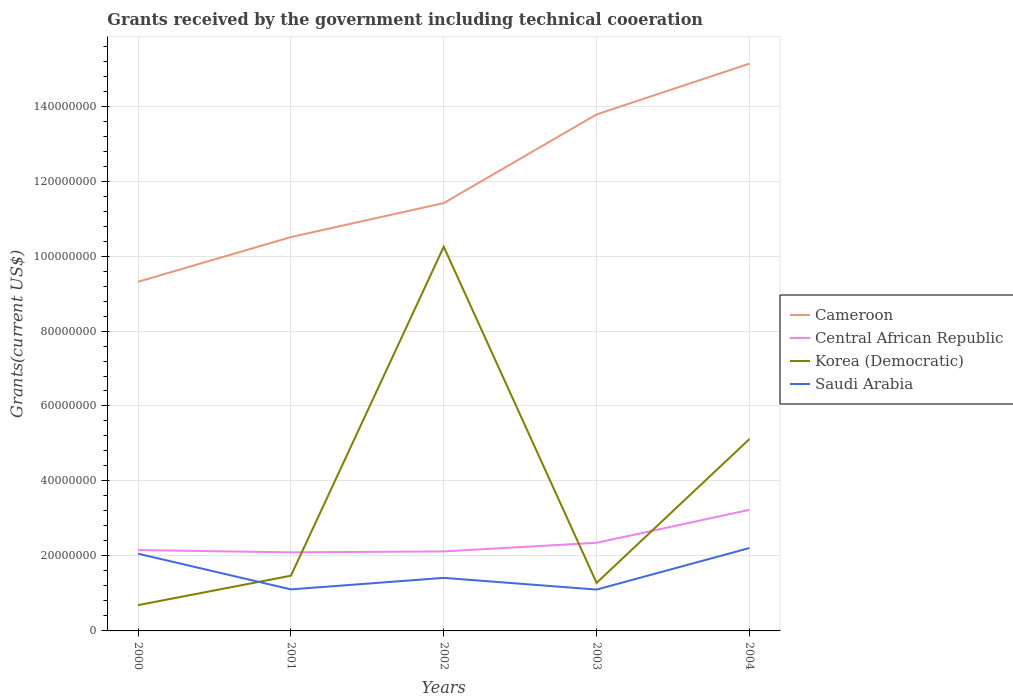How many different coloured lines are there?
Provide a succinct answer. 4. Does the line corresponding to Central African Republic intersect with the line corresponding to Saudi Arabia?
Offer a very short reply. No. Across all years, what is the maximum total grants received by the government in Cameroon?
Your answer should be compact. 9.31e+07. What is the total total grants received by the government in Korea (Democratic) in the graph?
Provide a succinct answer. -3.84e+07. What is the difference between the highest and the second highest total grants received by the government in Saudi Arabia?
Your response must be concise. 1.11e+07. How many years are there in the graph?
Your response must be concise. 5. Does the graph contain grids?
Ensure brevity in your answer.  Yes. Where does the legend appear in the graph?
Your answer should be very brief. Center right. How are the legend labels stacked?
Ensure brevity in your answer.  Vertical. What is the title of the graph?
Offer a terse response. Grants received by the government including technical cooeration. Does "World" appear as one of the legend labels in the graph?
Ensure brevity in your answer.  No. What is the label or title of the X-axis?
Keep it short and to the point. Years. What is the label or title of the Y-axis?
Your answer should be compact. Grants(current US$). What is the Grants(current US$) of Cameroon in 2000?
Your answer should be very brief. 9.31e+07. What is the Grants(current US$) in Central African Republic in 2000?
Offer a very short reply. 2.16e+07. What is the Grants(current US$) in Korea (Democratic) in 2000?
Your answer should be compact. 6.88e+06. What is the Grants(current US$) of Saudi Arabia in 2000?
Make the answer very short. 2.06e+07. What is the Grants(current US$) in Cameroon in 2001?
Keep it short and to the point. 1.05e+08. What is the Grants(current US$) of Central African Republic in 2001?
Make the answer very short. 2.10e+07. What is the Grants(current US$) in Korea (Democratic) in 2001?
Give a very brief answer. 1.47e+07. What is the Grants(current US$) of Saudi Arabia in 2001?
Give a very brief answer. 1.11e+07. What is the Grants(current US$) in Cameroon in 2002?
Keep it short and to the point. 1.14e+08. What is the Grants(current US$) in Central African Republic in 2002?
Offer a terse response. 2.12e+07. What is the Grants(current US$) of Korea (Democratic) in 2002?
Ensure brevity in your answer.  1.02e+08. What is the Grants(current US$) of Saudi Arabia in 2002?
Your answer should be very brief. 1.42e+07. What is the Grants(current US$) of Cameroon in 2003?
Provide a short and direct response. 1.38e+08. What is the Grants(current US$) of Central African Republic in 2003?
Offer a very short reply. 2.35e+07. What is the Grants(current US$) of Korea (Democratic) in 2003?
Give a very brief answer. 1.28e+07. What is the Grants(current US$) in Saudi Arabia in 2003?
Your answer should be very brief. 1.10e+07. What is the Grants(current US$) of Cameroon in 2004?
Your response must be concise. 1.51e+08. What is the Grants(current US$) of Central African Republic in 2004?
Provide a short and direct response. 3.23e+07. What is the Grants(current US$) of Korea (Democratic) in 2004?
Your answer should be compact. 5.12e+07. What is the Grants(current US$) of Saudi Arabia in 2004?
Provide a succinct answer. 2.21e+07. Across all years, what is the maximum Grants(current US$) of Cameroon?
Your answer should be very brief. 1.51e+08. Across all years, what is the maximum Grants(current US$) of Central African Republic?
Make the answer very short. 3.23e+07. Across all years, what is the maximum Grants(current US$) of Korea (Democratic)?
Provide a short and direct response. 1.02e+08. Across all years, what is the maximum Grants(current US$) of Saudi Arabia?
Your response must be concise. 2.21e+07. Across all years, what is the minimum Grants(current US$) in Cameroon?
Provide a short and direct response. 9.31e+07. Across all years, what is the minimum Grants(current US$) in Central African Republic?
Make the answer very short. 2.10e+07. Across all years, what is the minimum Grants(current US$) in Korea (Democratic)?
Your answer should be compact. 6.88e+06. Across all years, what is the minimum Grants(current US$) in Saudi Arabia?
Make the answer very short. 1.10e+07. What is the total Grants(current US$) in Cameroon in the graph?
Your answer should be compact. 6.01e+08. What is the total Grants(current US$) in Central African Republic in the graph?
Keep it short and to the point. 1.20e+08. What is the total Grants(current US$) in Korea (Democratic) in the graph?
Offer a terse response. 1.88e+08. What is the total Grants(current US$) in Saudi Arabia in the graph?
Keep it short and to the point. 7.90e+07. What is the difference between the Grants(current US$) of Cameroon in 2000 and that in 2001?
Give a very brief answer. -1.19e+07. What is the difference between the Grants(current US$) of Central African Republic in 2000 and that in 2001?
Offer a terse response. 6.10e+05. What is the difference between the Grants(current US$) of Korea (Democratic) in 2000 and that in 2001?
Offer a terse response. -7.85e+06. What is the difference between the Grants(current US$) of Saudi Arabia in 2000 and that in 2001?
Ensure brevity in your answer.  9.52e+06. What is the difference between the Grants(current US$) of Cameroon in 2000 and that in 2002?
Give a very brief answer. -2.10e+07. What is the difference between the Grants(current US$) in Korea (Democratic) in 2000 and that in 2002?
Your response must be concise. -9.56e+07. What is the difference between the Grants(current US$) of Saudi Arabia in 2000 and that in 2002?
Offer a terse response. 6.45e+06. What is the difference between the Grants(current US$) in Cameroon in 2000 and that in 2003?
Provide a short and direct response. -4.46e+07. What is the difference between the Grants(current US$) in Central African Republic in 2000 and that in 2003?
Ensure brevity in your answer.  -1.94e+06. What is the difference between the Grants(current US$) in Korea (Democratic) in 2000 and that in 2003?
Offer a terse response. -5.94e+06. What is the difference between the Grants(current US$) in Saudi Arabia in 2000 and that in 2003?
Offer a very short reply. 9.57e+06. What is the difference between the Grants(current US$) of Cameroon in 2000 and that in 2004?
Give a very brief answer. -5.82e+07. What is the difference between the Grants(current US$) of Central African Republic in 2000 and that in 2004?
Offer a terse response. -1.07e+07. What is the difference between the Grants(current US$) of Korea (Democratic) in 2000 and that in 2004?
Make the answer very short. -4.43e+07. What is the difference between the Grants(current US$) in Saudi Arabia in 2000 and that in 2004?
Offer a very short reply. -1.51e+06. What is the difference between the Grants(current US$) in Cameroon in 2001 and that in 2002?
Offer a very short reply. -9.07e+06. What is the difference between the Grants(current US$) of Korea (Democratic) in 2001 and that in 2002?
Give a very brief answer. -8.77e+07. What is the difference between the Grants(current US$) of Saudi Arabia in 2001 and that in 2002?
Make the answer very short. -3.07e+06. What is the difference between the Grants(current US$) in Cameroon in 2001 and that in 2003?
Keep it short and to the point. -3.27e+07. What is the difference between the Grants(current US$) in Central African Republic in 2001 and that in 2003?
Provide a succinct answer. -2.55e+06. What is the difference between the Grants(current US$) of Korea (Democratic) in 2001 and that in 2003?
Your response must be concise. 1.91e+06. What is the difference between the Grants(current US$) in Cameroon in 2001 and that in 2004?
Your answer should be very brief. -4.63e+07. What is the difference between the Grants(current US$) of Central African Republic in 2001 and that in 2004?
Your answer should be very brief. -1.13e+07. What is the difference between the Grants(current US$) in Korea (Democratic) in 2001 and that in 2004?
Give a very brief answer. -3.64e+07. What is the difference between the Grants(current US$) of Saudi Arabia in 2001 and that in 2004?
Your answer should be compact. -1.10e+07. What is the difference between the Grants(current US$) in Cameroon in 2002 and that in 2003?
Give a very brief answer. -2.36e+07. What is the difference between the Grants(current US$) of Central African Republic in 2002 and that in 2003?
Your answer should be very brief. -2.30e+06. What is the difference between the Grants(current US$) in Korea (Democratic) in 2002 and that in 2003?
Offer a terse response. 8.96e+07. What is the difference between the Grants(current US$) in Saudi Arabia in 2002 and that in 2003?
Offer a terse response. 3.12e+06. What is the difference between the Grants(current US$) in Cameroon in 2002 and that in 2004?
Offer a very short reply. -3.72e+07. What is the difference between the Grants(current US$) in Central African Republic in 2002 and that in 2004?
Your answer should be very brief. -1.11e+07. What is the difference between the Grants(current US$) of Korea (Democratic) in 2002 and that in 2004?
Your response must be concise. 5.13e+07. What is the difference between the Grants(current US$) of Saudi Arabia in 2002 and that in 2004?
Offer a very short reply. -7.96e+06. What is the difference between the Grants(current US$) in Cameroon in 2003 and that in 2004?
Keep it short and to the point. -1.35e+07. What is the difference between the Grants(current US$) in Central African Republic in 2003 and that in 2004?
Your answer should be compact. -8.79e+06. What is the difference between the Grants(current US$) of Korea (Democratic) in 2003 and that in 2004?
Offer a very short reply. -3.84e+07. What is the difference between the Grants(current US$) in Saudi Arabia in 2003 and that in 2004?
Provide a short and direct response. -1.11e+07. What is the difference between the Grants(current US$) in Cameroon in 2000 and the Grants(current US$) in Central African Republic in 2001?
Ensure brevity in your answer.  7.22e+07. What is the difference between the Grants(current US$) of Cameroon in 2000 and the Grants(current US$) of Korea (Democratic) in 2001?
Offer a very short reply. 7.84e+07. What is the difference between the Grants(current US$) in Cameroon in 2000 and the Grants(current US$) in Saudi Arabia in 2001?
Keep it short and to the point. 8.20e+07. What is the difference between the Grants(current US$) in Central African Republic in 2000 and the Grants(current US$) in Korea (Democratic) in 2001?
Provide a short and direct response. 6.84e+06. What is the difference between the Grants(current US$) of Central African Republic in 2000 and the Grants(current US$) of Saudi Arabia in 2001?
Offer a terse response. 1.05e+07. What is the difference between the Grants(current US$) in Korea (Democratic) in 2000 and the Grants(current US$) in Saudi Arabia in 2001?
Your response must be concise. -4.20e+06. What is the difference between the Grants(current US$) of Cameroon in 2000 and the Grants(current US$) of Central African Republic in 2002?
Keep it short and to the point. 7.19e+07. What is the difference between the Grants(current US$) in Cameroon in 2000 and the Grants(current US$) in Korea (Democratic) in 2002?
Offer a terse response. -9.34e+06. What is the difference between the Grants(current US$) in Cameroon in 2000 and the Grants(current US$) in Saudi Arabia in 2002?
Your answer should be very brief. 7.90e+07. What is the difference between the Grants(current US$) of Central African Republic in 2000 and the Grants(current US$) of Korea (Democratic) in 2002?
Offer a very short reply. -8.09e+07. What is the difference between the Grants(current US$) in Central African Republic in 2000 and the Grants(current US$) in Saudi Arabia in 2002?
Your answer should be very brief. 7.42e+06. What is the difference between the Grants(current US$) in Korea (Democratic) in 2000 and the Grants(current US$) in Saudi Arabia in 2002?
Keep it short and to the point. -7.27e+06. What is the difference between the Grants(current US$) of Cameroon in 2000 and the Grants(current US$) of Central African Republic in 2003?
Ensure brevity in your answer.  6.96e+07. What is the difference between the Grants(current US$) in Cameroon in 2000 and the Grants(current US$) in Korea (Democratic) in 2003?
Your response must be concise. 8.03e+07. What is the difference between the Grants(current US$) of Cameroon in 2000 and the Grants(current US$) of Saudi Arabia in 2003?
Offer a very short reply. 8.21e+07. What is the difference between the Grants(current US$) in Central African Republic in 2000 and the Grants(current US$) in Korea (Democratic) in 2003?
Provide a short and direct response. 8.75e+06. What is the difference between the Grants(current US$) of Central African Republic in 2000 and the Grants(current US$) of Saudi Arabia in 2003?
Give a very brief answer. 1.05e+07. What is the difference between the Grants(current US$) of Korea (Democratic) in 2000 and the Grants(current US$) of Saudi Arabia in 2003?
Make the answer very short. -4.15e+06. What is the difference between the Grants(current US$) of Cameroon in 2000 and the Grants(current US$) of Central African Republic in 2004?
Your answer should be very brief. 6.08e+07. What is the difference between the Grants(current US$) of Cameroon in 2000 and the Grants(current US$) of Korea (Democratic) in 2004?
Ensure brevity in your answer.  4.20e+07. What is the difference between the Grants(current US$) in Cameroon in 2000 and the Grants(current US$) in Saudi Arabia in 2004?
Offer a terse response. 7.10e+07. What is the difference between the Grants(current US$) in Central African Republic in 2000 and the Grants(current US$) in Korea (Democratic) in 2004?
Your response must be concise. -2.96e+07. What is the difference between the Grants(current US$) in Central African Republic in 2000 and the Grants(current US$) in Saudi Arabia in 2004?
Offer a terse response. -5.40e+05. What is the difference between the Grants(current US$) in Korea (Democratic) in 2000 and the Grants(current US$) in Saudi Arabia in 2004?
Offer a terse response. -1.52e+07. What is the difference between the Grants(current US$) of Cameroon in 2001 and the Grants(current US$) of Central African Republic in 2002?
Ensure brevity in your answer.  8.38e+07. What is the difference between the Grants(current US$) of Cameroon in 2001 and the Grants(current US$) of Korea (Democratic) in 2002?
Provide a succinct answer. 2.59e+06. What is the difference between the Grants(current US$) in Cameroon in 2001 and the Grants(current US$) in Saudi Arabia in 2002?
Your response must be concise. 9.09e+07. What is the difference between the Grants(current US$) of Central African Republic in 2001 and the Grants(current US$) of Korea (Democratic) in 2002?
Give a very brief answer. -8.15e+07. What is the difference between the Grants(current US$) in Central African Republic in 2001 and the Grants(current US$) in Saudi Arabia in 2002?
Provide a short and direct response. 6.81e+06. What is the difference between the Grants(current US$) of Korea (Democratic) in 2001 and the Grants(current US$) of Saudi Arabia in 2002?
Your response must be concise. 5.80e+05. What is the difference between the Grants(current US$) in Cameroon in 2001 and the Grants(current US$) in Central African Republic in 2003?
Make the answer very short. 8.16e+07. What is the difference between the Grants(current US$) in Cameroon in 2001 and the Grants(current US$) in Korea (Democratic) in 2003?
Keep it short and to the point. 9.22e+07. What is the difference between the Grants(current US$) of Cameroon in 2001 and the Grants(current US$) of Saudi Arabia in 2003?
Your answer should be very brief. 9.40e+07. What is the difference between the Grants(current US$) in Central African Republic in 2001 and the Grants(current US$) in Korea (Democratic) in 2003?
Provide a succinct answer. 8.14e+06. What is the difference between the Grants(current US$) in Central African Republic in 2001 and the Grants(current US$) in Saudi Arabia in 2003?
Provide a short and direct response. 9.93e+06. What is the difference between the Grants(current US$) of Korea (Democratic) in 2001 and the Grants(current US$) of Saudi Arabia in 2003?
Provide a short and direct response. 3.70e+06. What is the difference between the Grants(current US$) of Cameroon in 2001 and the Grants(current US$) of Central African Republic in 2004?
Offer a very short reply. 7.28e+07. What is the difference between the Grants(current US$) in Cameroon in 2001 and the Grants(current US$) in Korea (Democratic) in 2004?
Ensure brevity in your answer.  5.39e+07. What is the difference between the Grants(current US$) of Cameroon in 2001 and the Grants(current US$) of Saudi Arabia in 2004?
Ensure brevity in your answer.  8.30e+07. What is the difference between the Grants(current US$) in Central African Republic in 2001 and the Grants(current US$) in Korea (Democratic) in 2004?
Give a very brief answer. -3.02e+07. What is the difference between the Grants(current US$) of Central African Republic in 2001 and the Grants(current US$) of Saudi Arabia in 2004?
Offer a terse response. -1.15e+06. What is the difference between the Grants(current US$) of Korea (Democratic) in 2001 and the Grants(current US$) of Saudi Arabia in 2004?
Ensure brevity in your answer.  -7.38e+06. What is the difference between the Grants(current US$) in Cameroon in 2002 and the Grants(current US$) in Central African Republic in 2003?
Offer a terse response. 9.06e+07. What is the difference between the Grants(current US$) of Cameroon in 2002 and the Grants(current US$) of Korea (Democratic) in 2003?
Offer a terse response. 1.01e+08. What is the difference between the Grants(current US$) in Cameroon in 2002 and the Grants(current US$) in Saudi Arabia in 2003?
Provide a short and direct response. 1.03e+08. What is the difference between the Grants(current US$) of Central African Republic in 2002 and the Grants(current US$) of Korea (Democratic) in 2003?
Your response must be concise. 8.39e+06. What is the difference between the Grants(current US$) in Central African Republic in 2002 and the Grants(current US$) in Saudi Arabia in 2003?
Provide a succinct answer. 1.02e+07. What is the difference between the Grants(current US$) of Korea (Democratic) in 2002 and the Grants(current US$) of Saudi Arabia in 2003?
Your answer should be compact. 9.14e+07. What is the difference between the Grants(current US$) of Cameroon in 2002 and the Grants(current US$) of Central African Republic in 2004?
Provide a short and direct response. 8.18e+07. What is the difference between the Grants(current US$) in Cameroon in 2002 and the Grants(current US$) in Korea (Democratic) in 2004?
Offer a very short reply. 6.30e+07. What is the difference between the Grants(current US$) in Cameroon in 2002 and the Grants(current US$) in Saudi Arabia in 2004?
Your response must be concise. 9.20e+07. What is the difference between the Grants(current US$) of Central African Republic in 2002 and the Grants(current US$) of Korea (Democratic) in 2004?
Your answer should be very brief. -3.00e+07. What is the difference between the Grants(current US$) of Central African Republic in 2002 and the Grants(current US$) of Saudi Arabia in 2004?
Give a very brief answer. -9.00e+05. What is the difference between the Grants(current US$) of Korea (Democratic) in 2002 and the Grants(current US$) of Saudi Arabia in 2004?
Offer a very short reply. 8.04e+07. What is the difference between the Grants(current US$) in Cameroon in 2003 and the Grants(current US$) in Central African Republic in 2004?
Provide a short and direct response. 1.05e+08. What is the difference between the Grants(current US$) of Cameroon in 2003 and the Grants(current US$) of Korea (Democratic) in 2004?
Ensure brevity in your answer.  8.66e+07. What is the difference between the Grants(current US$) of Cameroon in 2003 and the Grants(current US$) of Saudi Arabia in 2004?
Give a very brief answer. 1.16e+08. What is the difference between the Grants(current US$) of Central African Republic in 2003 and the Grants(current US$) of Korea (Democratic) in 2004?
Give a very brief answer. -2.77e+07. What is the difference between the Grants(current US$) in Central African Republic in 2003 and the Grants(current US$) in Saudi Arabia in 2004?
Make the answer very short. 1.40e+06. What is the difference between the Grants(current US$) in Korea (Democratic) in 2003 and the Grants(current US$) in Saudi Arabia in 2004?
Give a very brief answer. -9.29e+06. What is the average Grants(current US$) of Cameroon per year?
Give a very brief answer. 1.20e+08. What is the average Grants(current US$) of Central African Republic per year?
Ensure brevity in your answer.  2.39e+07. What is the average Grants(current US$) of Korea (Democratic) per year?
Offer a terse response. 3.76e+07. What is the average Grants(current US$) of Saudi Arabia per year?
Your answer should be compact. 1.58e+07. In the year 2000, what is the difference between the Grants(current US$) of Cameroon and Grants(current US$) of Central African Republic?
Keep it short and to the point. 7.16e+07. In the year 2000, what is the difference between the Grants(current US$) in Cameroon and Grants(current US$) in Korea (Democratic)?
Your answer should be compact. 8.62e+07. In the year 2000, what is the difference between the Grants(current US$) in Cameroon and Grants(current US$) in Saudi Arabia?
Make the answer very short. 7.25e+07. In the year 2000, what is the difference between the Grants(current US$) in Central African Republic and Grants(current US$) in Korea (Democratic)?
Provide a succinct answer. 1.47e+07. In the year 2000, what is the difference between the Grants(current US$) of Central African Republic and Grants(current US$) of Saudi Arabia?
Give a very brief answer. 9.70e+05. In the year 2000, what is the difference between the Grants(current US$) in Korea (Democratic) and Grants(current US$) in Saudi Arabia?
Your answer should be very brief. -1.37e+07. In the year 2001, what is the difference between the Grants(current US$) in Cameroon and Grants(current US$) in Central African Republic?
Offer a very short reply. 8.41e+07. In the year 2001, what is the difference between the Grants(current US$) in Cameroon and Grants(current US$) in Korea (Democratic)?
Provide a short and direct response. 9.03e+07. In the year 2001, what is the difference between the Grants(current US$) in Cameroon and Grants(current US$) in Saudi Arabia?
Provide a short and direct response. 9.40e+07. In the year 2001, what is the difference between the Grants(current US$) in Central African Republic and Grants(current US$) in Korea (Democratic)?
Provide a succinct answer. 6.23e+06. In the year 2001, what is the difference between the Grants(current US$) in Central African Republic and Grants(current US$) in Saudi Arabia?
Provide a short and direct response. 9.88e+06. In the year 2001, what is the difference between the Grants(current US$) of Korea (Democratic) and Grants(current US$) of Saudi Arabia?
Give a very brief answer. 3.65e+06. In the year 2002, what is the difference between the Grants(current US$) of Cameroon and Grants(current US$) of Central African Republic?
Ensure brevity in your answer.  9.29e+07. In the year 2002, what is the difference between the Grants(current US$) in Cameroon and Grants(current US$) in Korea (Democratic)?
Give a very brief answer. 1.17e+07. In the year 2002, what is the difference between the Grants(current US$) in Cameroon and Grants(current US$) in Saudi Arabia?
Offer a very short reply. 1.00e+08. In the year 2002, what is the difference between the Grants(current US$) in Central African Republic and Grants(current US$) in Korea (Democratic)?
Give a very brief answer. -8.13e+07. In the year 2002, what is the difference between the Grants(current US$) of Central African Republic and Grants(current US$) of Saudi Arabia?
Offer a terse response. 7.06e+06. In the year 2002, what is the difference between the Grants(current US$) in Korea (Democratic) and Grants(current US$) in Saudi Arabia?
Ensure brevity in your answer.  8.83e+07. In the year 2003, what is the difference between the Grants(current US$) in Cameroon and Grants(current US$) in Central African Republic?
Your answer should be very brief. 1.14e+08. In the year 2003, what is the difference between the Grants(current US$) in Cameroon and Grants(current US$) in Korea (Democratic)?
Your answer should be very brief. 1.25e+08. In the year 2003, what is the difference between the Grants(current US$) of Cameroon and Grants(current US$) of Saudi Arabia?
Your answer should be compact. 1.27e+08. In the year 2003, what is the difference between the Grants(current US$) of Central African Republic and Grants(current US$) of Korea (Democratic)?
Give a very brief answer. 1.07e+07. In the year 2003, what is the difference between the Grants(current US$) in Central African Republic and Grants(current US$) in Saudi Arabia?
Your response must be concise. 1.25e+07. In the year 2003, what is the difference between the Grants(current US$) of Korea (Democratic) and Grants(current US$) of Saudi Arabia?
Keep it short and to the point. 1.79e+06. In the year 2004, what is the difference between the Grants(current US$) in Cameroon and Grants(current US$) in Central African Republic?
Your response must be concise. 1.19e+08. In the year 2004, what is the difference between the Grants(current US$) of Cameroon and Grants(current US$) of Korea (Democratic)?
Your response must be concise. 1.00e+08. In the year 2004, what is the difference between the Grants(current US$) in Cameroon and Grants(current US$) in Saudi Arabia?
Offer a terse response. 1.29e+08. In the year 2004, what is the difference between the Grants(current US$) in Central African Republic and Grants(current US$) in Korea (Democratic)?
Keep it short and to the point. -1.89e+07. In the year 2004, what is the difference between the Grants(current US$) of Central African Republic and Grants(current US$) of Saudi Arabia?
Give a very brief answer. 1.02e+07. In the year 2004, what is the difference between the Grants(current US$) of Korea (Democratic) and Grants(current US$) of Saudi Arabia?
Offer a terse response. 2.91e+07. What is the ratio of the Grants(current US$) of Cameroon in 2000 to that in 2001?
Your answer should be very brief. 0.89. What is the ratio of the Grants(current US$) in Central African Republic in 2000 to that in 2001?
Make the answer very short. 1.03. What is the ratio of the Grants(current US$) of Korea (Democratic) in 2000 to that in 2001?
Give a very brief answer. 0.47. What is the ratio of the Grants(current US$) in Saudi Arabia in 2000 to that in 2001?
Your response must be concise. 1.86. What is the ratio of the Grants(current US$) of Cameroon in 2000 to that in 2002?
Offer a very short reply. 0.82. What is the ratio of the Grants(current US$) of Central African Republic in 2000 to that in 2002?
Offer a very short reply. 1.02. What is the ratio of the Grants(current US$) in Korea (Democratic) in 2000 to that in 2002?
Make the answer very short. 0.07. What is the ratio of the Grants(current US$) in Saudi Arabia in 2000 to that in 2002?
Your answer should be very brief. 1.46. What is the ratio of the Grants(current US$) of Cameroon in 2000 to that in 2003?
Provide a short and direct response. 0.68. What is the ratio of the Grants(current US$) in Central African Republic in 2000 to that in 2003?
Your answer should be very brief. 0.92. What is the ratio of the Grants(current US$) in Korea (Democratic) in 2000 to that in 2003?
Provide a succinct answer. 0.54. What is the ratio of the Grants(current US$) of Saudi Arabia in 2000 to that in 2003?
Your response must be concise. 1.87. What is the ratio of the Grants(current US$) of Cameroon in 2000 to that in 2004?
Offer a terse response. 0.62. What is the ratio of the Grants(current US$) in Central African Republic in 2000 to that in 2004?
Make the answer very short. 0.67. What is the ratio of the Grants(current US$) in Korea (Democratic) in 2000 to that in 2004?
Give a very brief answer. 0.13. What is the ratio of the Grants(current US$) of Saudi Arabia in 2000 to that in 2004?
Keep it short and to the point. 0.93. What is the ratio of the Grants(current US$) in Cameroon in 2001 to that in 2002?
Your answer should be very brief. 0.92. What is the ratio of the Grants(current US$) in Korea (Democratic) in 2001 to that in 2002?
Provide a short and direct response. 0.14. What is the ratio of the Grants(current US$) of Saudi Arabia in 2001 to that in 2002?
Offer a terse response. 0.78. What is the ratio of the Grants(current US$) in Cameroon in 2001 to that in 2003?
Provide a short and direct response. 0.76. What is the ratio of the Grants(current US$) of Central African Republic in 2001 to that in 2003?
Offer a terse response. 0.89. What is the ratio of the Grants(current US$) in Korea (Democratic) in 2001 to that in 2003?
Provide a short and direct response. 1.15. What is the ratio of the Grants(current US$) of Cameroon in 2001 to that in 2004?
Make the answer very short. 0.69. What is the ratio of the Grants(current US$) of Central African Republic in 2001 to that in 2004?
Keep it short and to the point. 0.65. What is the ratio of the Grants(current US$) of Korea (Democratic) in 2001 to that in 2004?
Offer a very short reply. 0.29. What is the ratio of the Grants(current US$) of Saudi Arabia in 2001 to that in 2004?
Give a very brief answer. 0.5. What is the ratio of the Grants(current US$) in Cameroon in 2002 to that in 2003?
Give a very brief answer. 0.83. What is the ratio of the Grants(current US$) of Central African Republic in 2002 to that in 2003?
Offer a terse response. 0.9. What is the ratio of the Grants(current US$) of Korea (Democratic) in 2002 to that in 2003?
Make the answer very short. 7.99. What is the ratio of the Grants(current US$) in Saudi Arabia in 2002 to that in 2003?
Your response must be concise. 1.28. What is the ratio of the Grants(current US$) of Cameroon in 2002 to that in 2004?
Provide a succinct answer. 0.75. What is the ratio of the Grants(current US$) in Central African Republic in 2002 to that in 2004?
Ensure brevity in your answer.  0.66. What is the ratio of the Grants(current US$) of Korea (Democratic) in 2002 to that in 2004?
Make the answer very short. 2. What is the ratio of the Grants(current US$) of Saudi Arabia in 2002 to that in 2004?
Your response must be concise. 0.64. What is the ratio of the Grants(current US$) in Cameroon in 2003 to that in 2004?
Ensure brevity in your answer.  0.91. What is the ratio of the Grants(current US$) in Central African Republic in 2003 to that in 2004?
Ensure brevity in your answer.  0.73. What is the ratio of the Grants(current US$) of Korea (Democratic) in 2003 to that in 2004?
Your response must be concise. 0.25. What is the ratio of the Grants(current US$) of Saudi Arabia in 2003 to that in 2004?
Provide a short and direct response. 0.5. What is the difference between the highest and the second highest Grants(current US$) in Cameroon?
Offer a terse response. 1.35e+07. What is the difference between the highest and the second highest Grants(current US$) in Central African Republic?
Keep it short and to the point. 8.79e+06. What is the difference between the highest and the second highest Grants(current US$) in Korea (Democratic)?
Your response must be concise. 5.13e+07. What is the difference between the highest and the second highest Grants(current US$) in Saudi Arabia?
Keep it short and to the point. 1.51e+06. What is the difference between the highest and the lowest Grants(current US$) in Cameroon?
Your answer should be compact. 5.82e+07. What is the difference between the highest and the lowest Grants(current US$) of Central African Republic?
Keep it short and to the point. 1.13e+07. What is the difference between the highest and the lowest Grants(current US$) of Korea (Democratic)?
Give a very brief answer. 9.56e+07. What is the difference between the highest and the lowest Grants(current US$) of Saudi Arabia?
Offer a very short reply. 1.11e+07. 